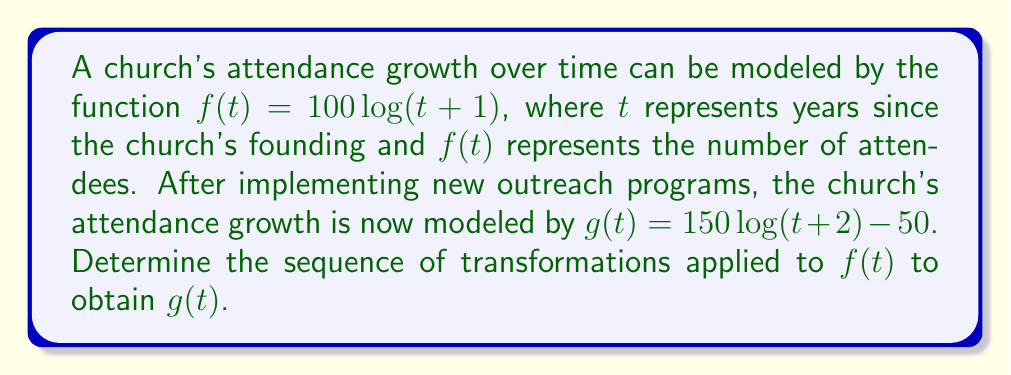Show me your answer to this math problem. To determine the sequence of transformations from $f(t)$ to $g(t)$, let's analyze the changes step by step:

1. Original function: $f(t) = 100\log(t+1)$

2. Inside the parentheses, we see $(t+2)$ instead of $(t+1)$:
   This represents a horizontal shift of 1 unit left.
   $100\log(t+1) \rightarrow 100\log(t+2)$

3. The coefficient of $\log$ changes from 100 to 150:
   This represents a vertical stretch by a factor of 1.5.
   $100\log(t+2) \rightarrow 150\log(t+2)$

4. Finally, we subtract 50 from the entire function:
   This represents a vertical shift of 50 units down.
   $150\log(t+2) \rightarrow 150\log(t+2) - 50$

Therefore, the sequence of transformations is:
a) Shift 1 unit left
b) Stretch vertically by a factor of 1.5
c) Shift 50 units down
Answer: Left 1, stretch 1.5 vertically, down 50 